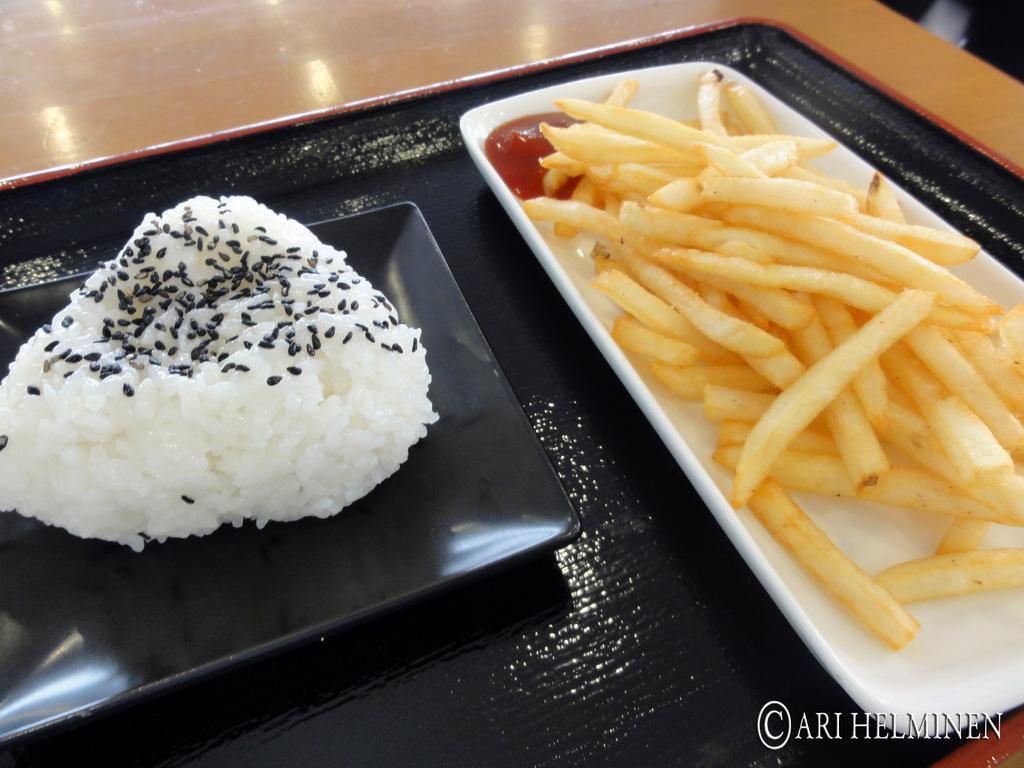Could you give a brief overview of what you see in this image? In this image we can see a tray on the table and there are two plates with food items on the tray. 